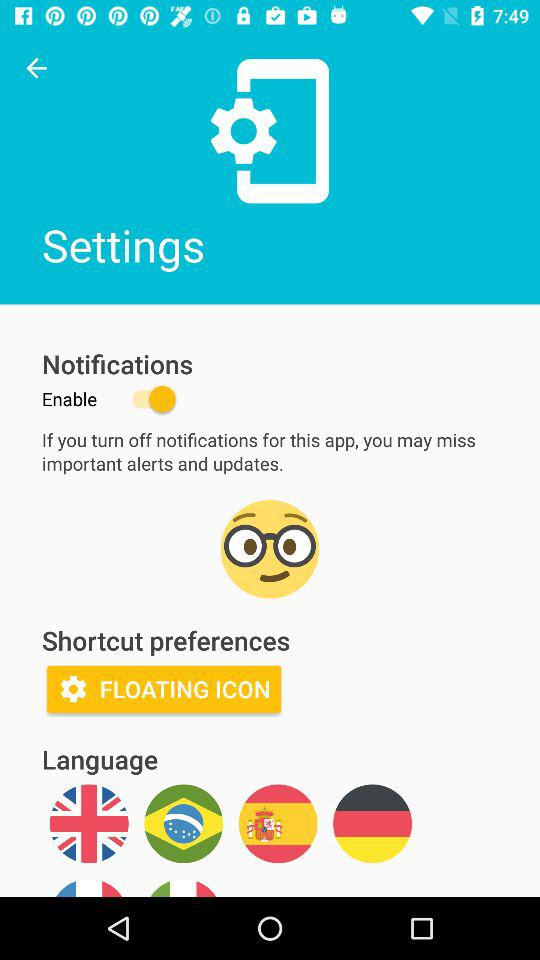What's the status of notifications? The status is on. 